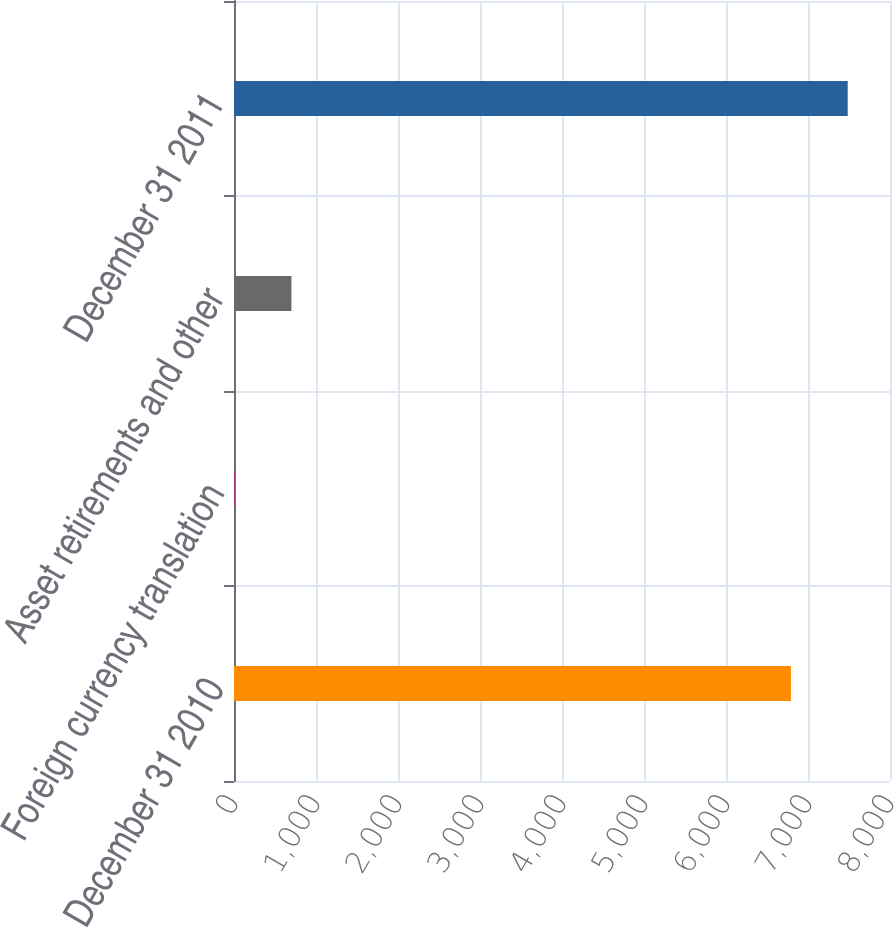<chart> <loc_0><loc_0><loc_500><loc_500><bar_chart><fcel>December 31 2010<fcel>Foreign currency translation<fcel>Asset retirements and other<fcel>December 31 2011<nl><fcel>6792<fcel>8<fcel>700.3<fcel>7484.3<nl></chart> 